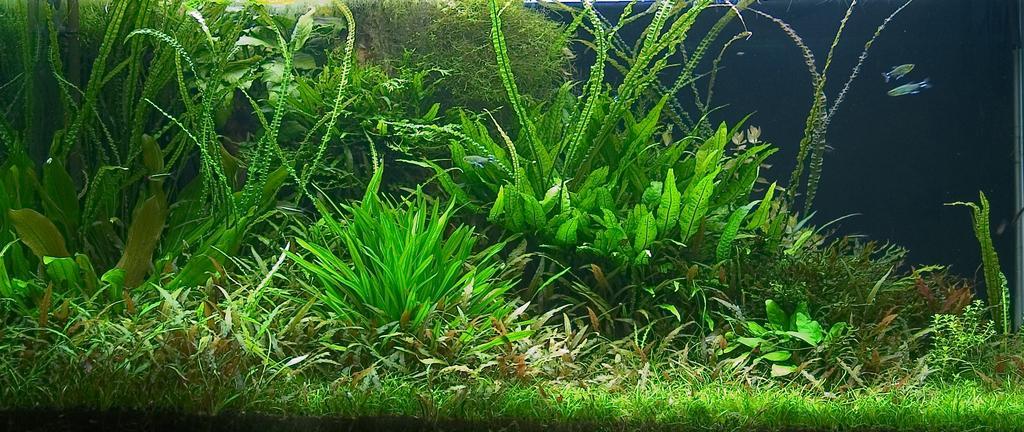Could you give a brief overview of what you see in this image? In this image we can see some plants which are green in color and on right side of the image there are two fishes. 